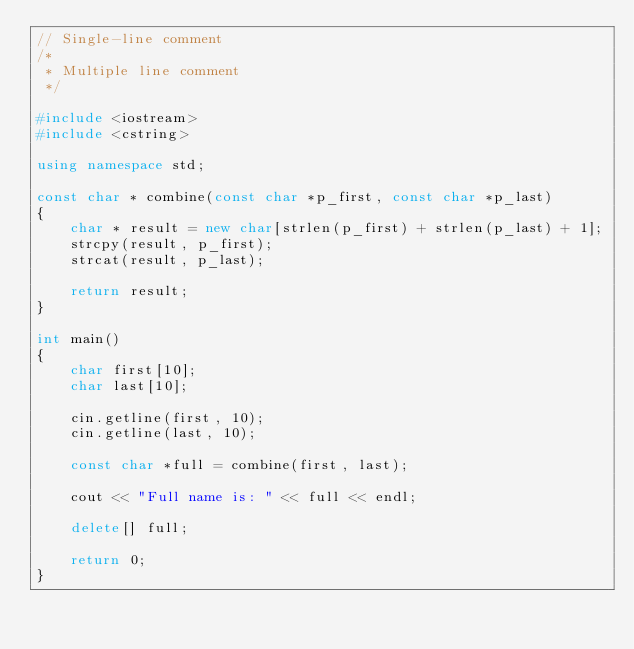Convert code to text. <code><loc_0><loc_0><loc_500><loc_500><_C++_>// Single-line comment
/*
 * Multiple line comment
 */

#include <iostream>
#include <cstring>

using namespace std;

const char * combine(const char *p_first, const char *p_last)
{
	char * result = new char[strlen(p_first) + strlen(p_last) + 1];
	strcpy(result, p_first);
	strcat(result, p_last);

	return result;
}

int main()
{
	char first[10];
	char last[10];

	cin.getline(first, 10);
	cin.getline(last, 10);

	const char *full = combine(first, last);

	cout << "Full name is: " << full << endl;

	delete[] full;

	return 0;
}
</code> 